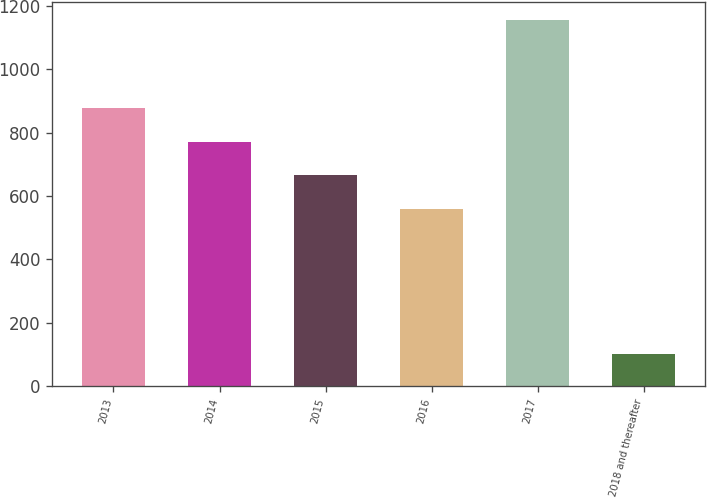Convert chart. <chart><loc_0><loc_0><loc_500><loc_500><bar_chart><fcel>2013<fcel>2014<fcel>2015<fcel>2016<fcel>2017<fcel>2018 and thereafter<nl><fcel>876.5<fcel>771<fcel>665.5<fcel>560<fcel>1155<fcel>100<nl></chart> 